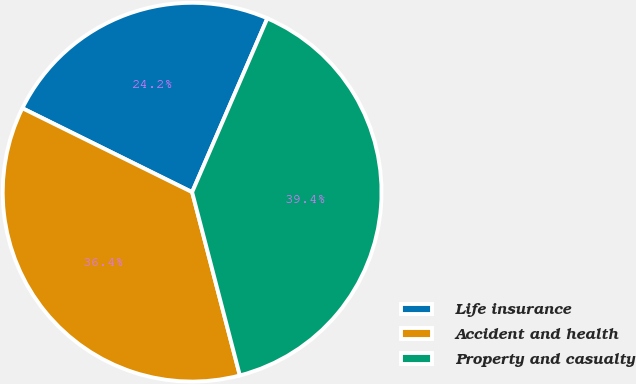Convert chart to OTSL. <chart><loc_0><loc_0><loc_500><loc_500><pie_chart><fcel>Life insurance<fcel>Accident and health<fcel>Property and casualty<nl><fcel>24.19%<fcel>36.37%<fcel>39.45%<nl></chart> 